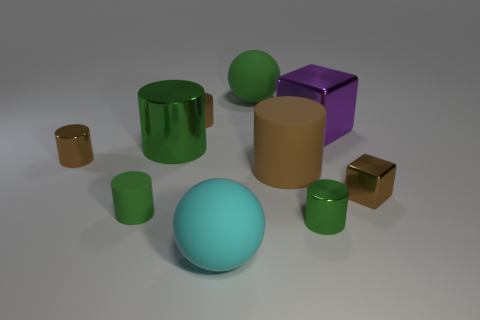How many other things are there of the same color as the small metal block?
Provide a short and direct response. 3. What number of big green things are in front of the brown thing behind the big green shiny thing?
Your answer should be very brief. 1. Are there any green things behind the small rubber object?
Make the answer very short. Yes. There is a green metal object in front of the small brown object that is on the right side of the large metal block; what is its shape?
Provide a succinct answer. Cylinder. Is the number of tiny blocks that are behind the large brown rubber cylinder less than the number of brown cylinders to the left of the big cyan rubber thing?
Your answer should be very brief. Yes. There is another tiny object that is the same shape as the purple object; what color is it?
Your response must be concise. Brown. What number of matte things are behind the big shiny cylinder and in front of the purple thing?
Offer a very short reply. 0. Is the number of large green rubber objects in front of the big cyan rubber sphere greater than the number of small green metallic objects on the right side of the big green matte object?
Offer a very short reply. No. The green rubber ball is what size?
Your response must be concise. Large. Is there a big green matte thing of the same shape as the brown matte object?
Keep it short and to the point. No. 